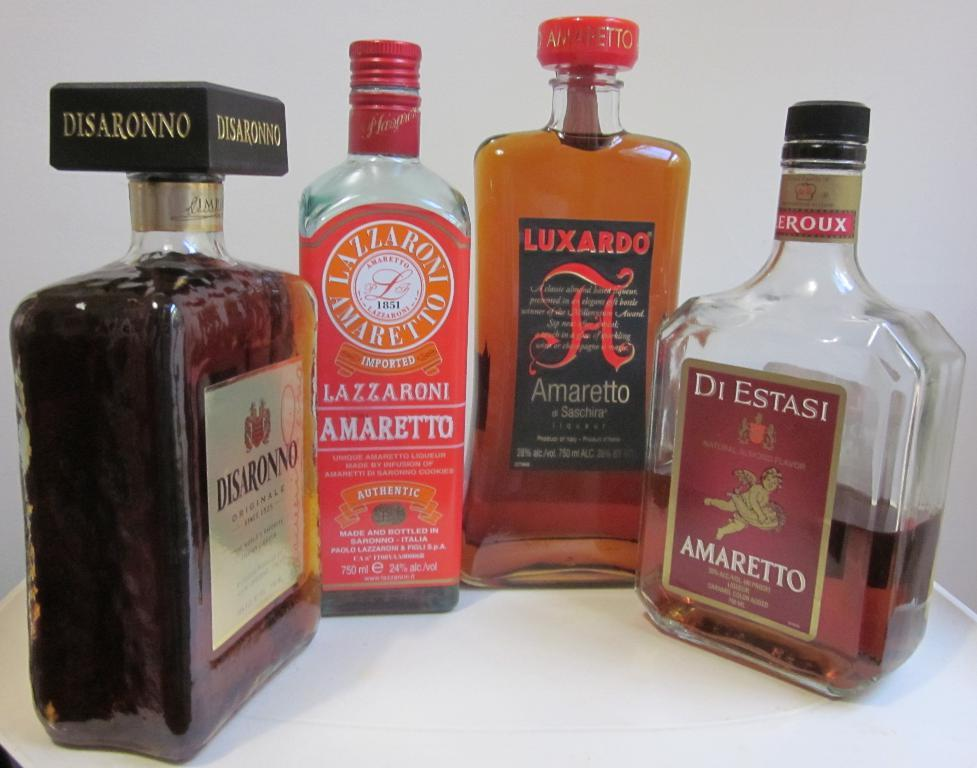<image>
Relay a brief, clear account of the picture shown. Four bottles of liquor, one is Di Estasi Amaretto. 